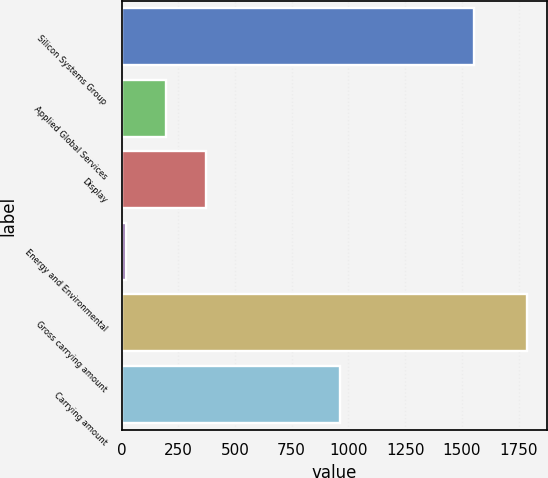Convert chart to OTSL. <chart><loc_0><loc_0><loc_500><loc_500><bar_chart><fcel>Silicon Systems Group<fcel>Applied Global Services<fcel>Display<fcel>Energy and Environmental<fcel>Gross carrying amount<fcel>Carrying amount<nl><fcel>1553<fcel>196.8<fcel>373.6<fcel>20<fcel>1788<fcel>961<nl></chart> 